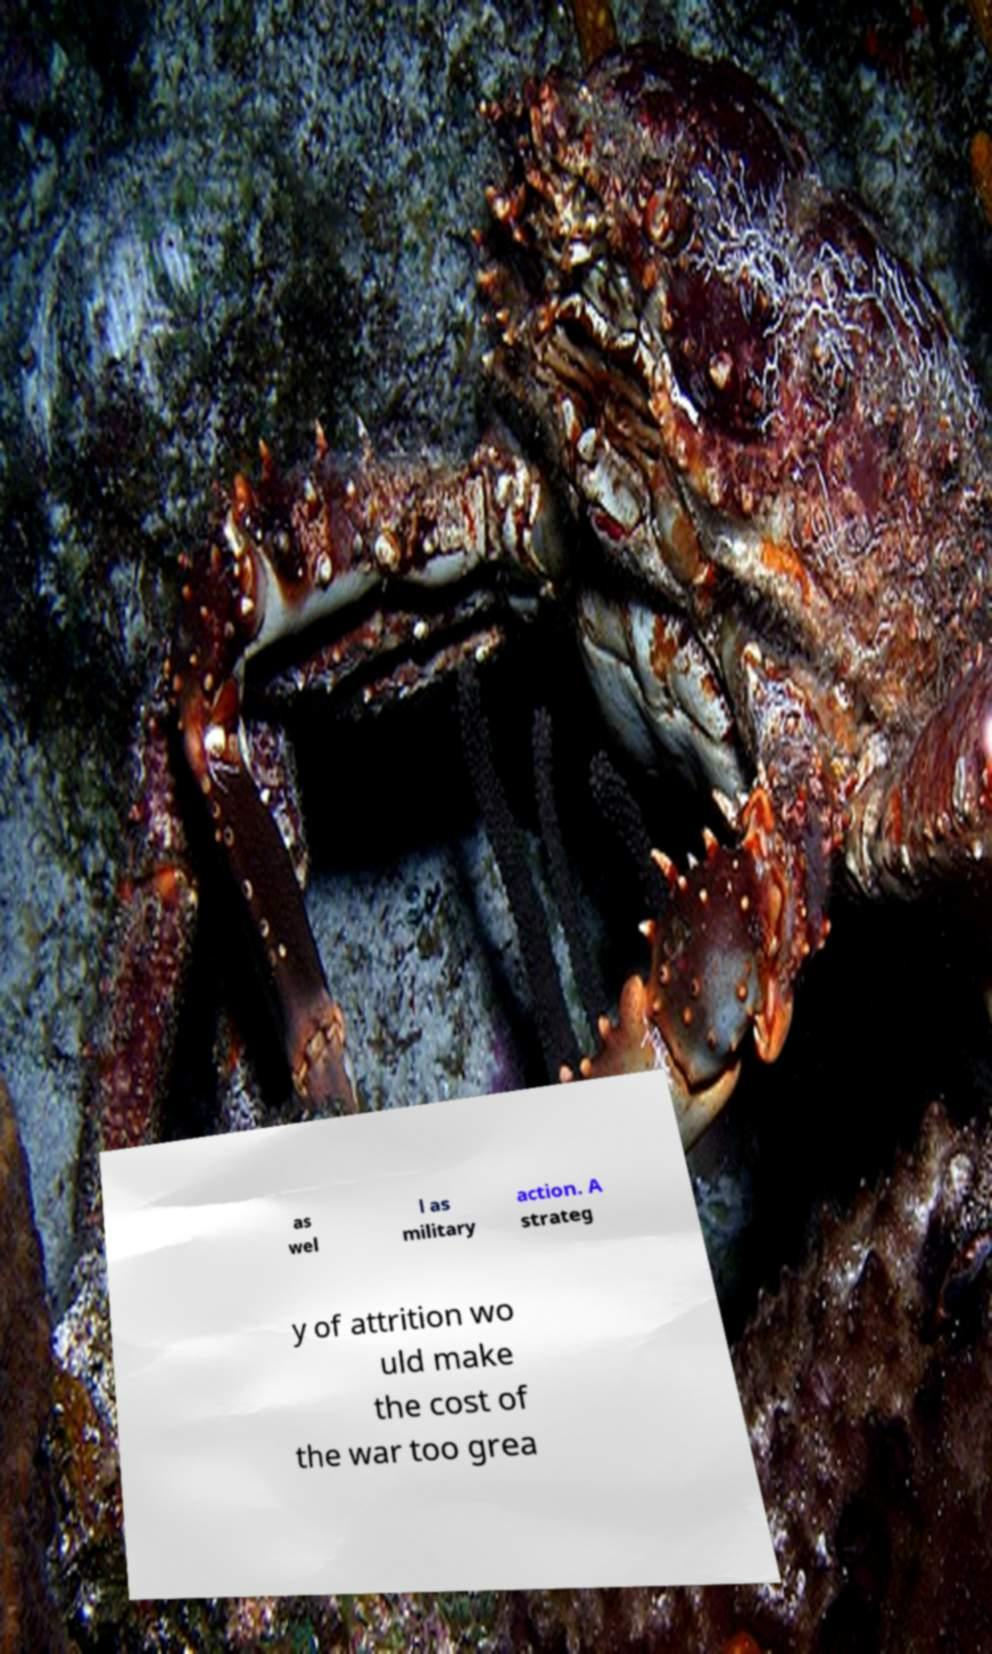There's text embedded in this image that I need extracted. Can you transcribe it verbatim? as wel l as military action. A strateg y of attrition wo uld make the cost of the war too grea 